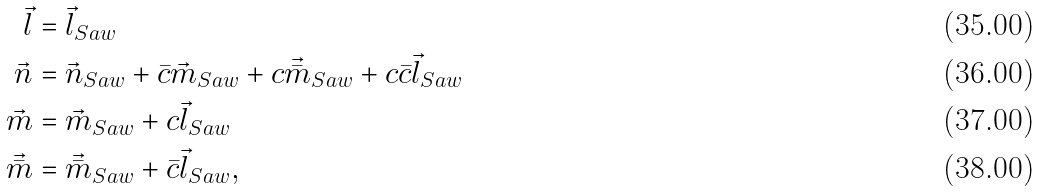<formula> <loc_0><loc_0><loc_500><loc_500>\vec { l } & = \vec { l } _ { S a w } \\ \vec { n } & = \vec { n } _ { S a w } + \bar { c } \vec { m } _ { S a w } + c \vec { \bar { m } } _ { S a w } + c \bar { c } \vec { l } _ { S a w } \\ \vec { m } & = \vec { m } _ { S a w } + c \vec { l } _ { S a w } \\ \vec { \bar { m } } & = \vec { \bar { m } } _ { S a w } + \bar { c } \vec { l } _ { S a w } ,</formula> 